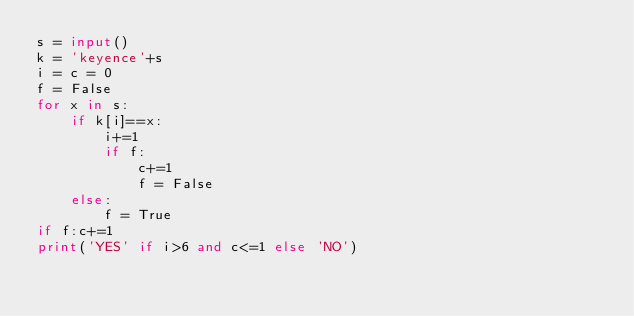<code> <loc_0><loc_0><loc_500><loc_500><_Python_>s = input()
k = 'keyence'+s
i = c = 0
f = False
for x in s:
    if k[i]==x:
        i+=1
        if f:
            c+=1
            f = False
    else:
        f = True
if f:c+=1
print('YES' if i>6 and c<=1 else 'NO')</code> 